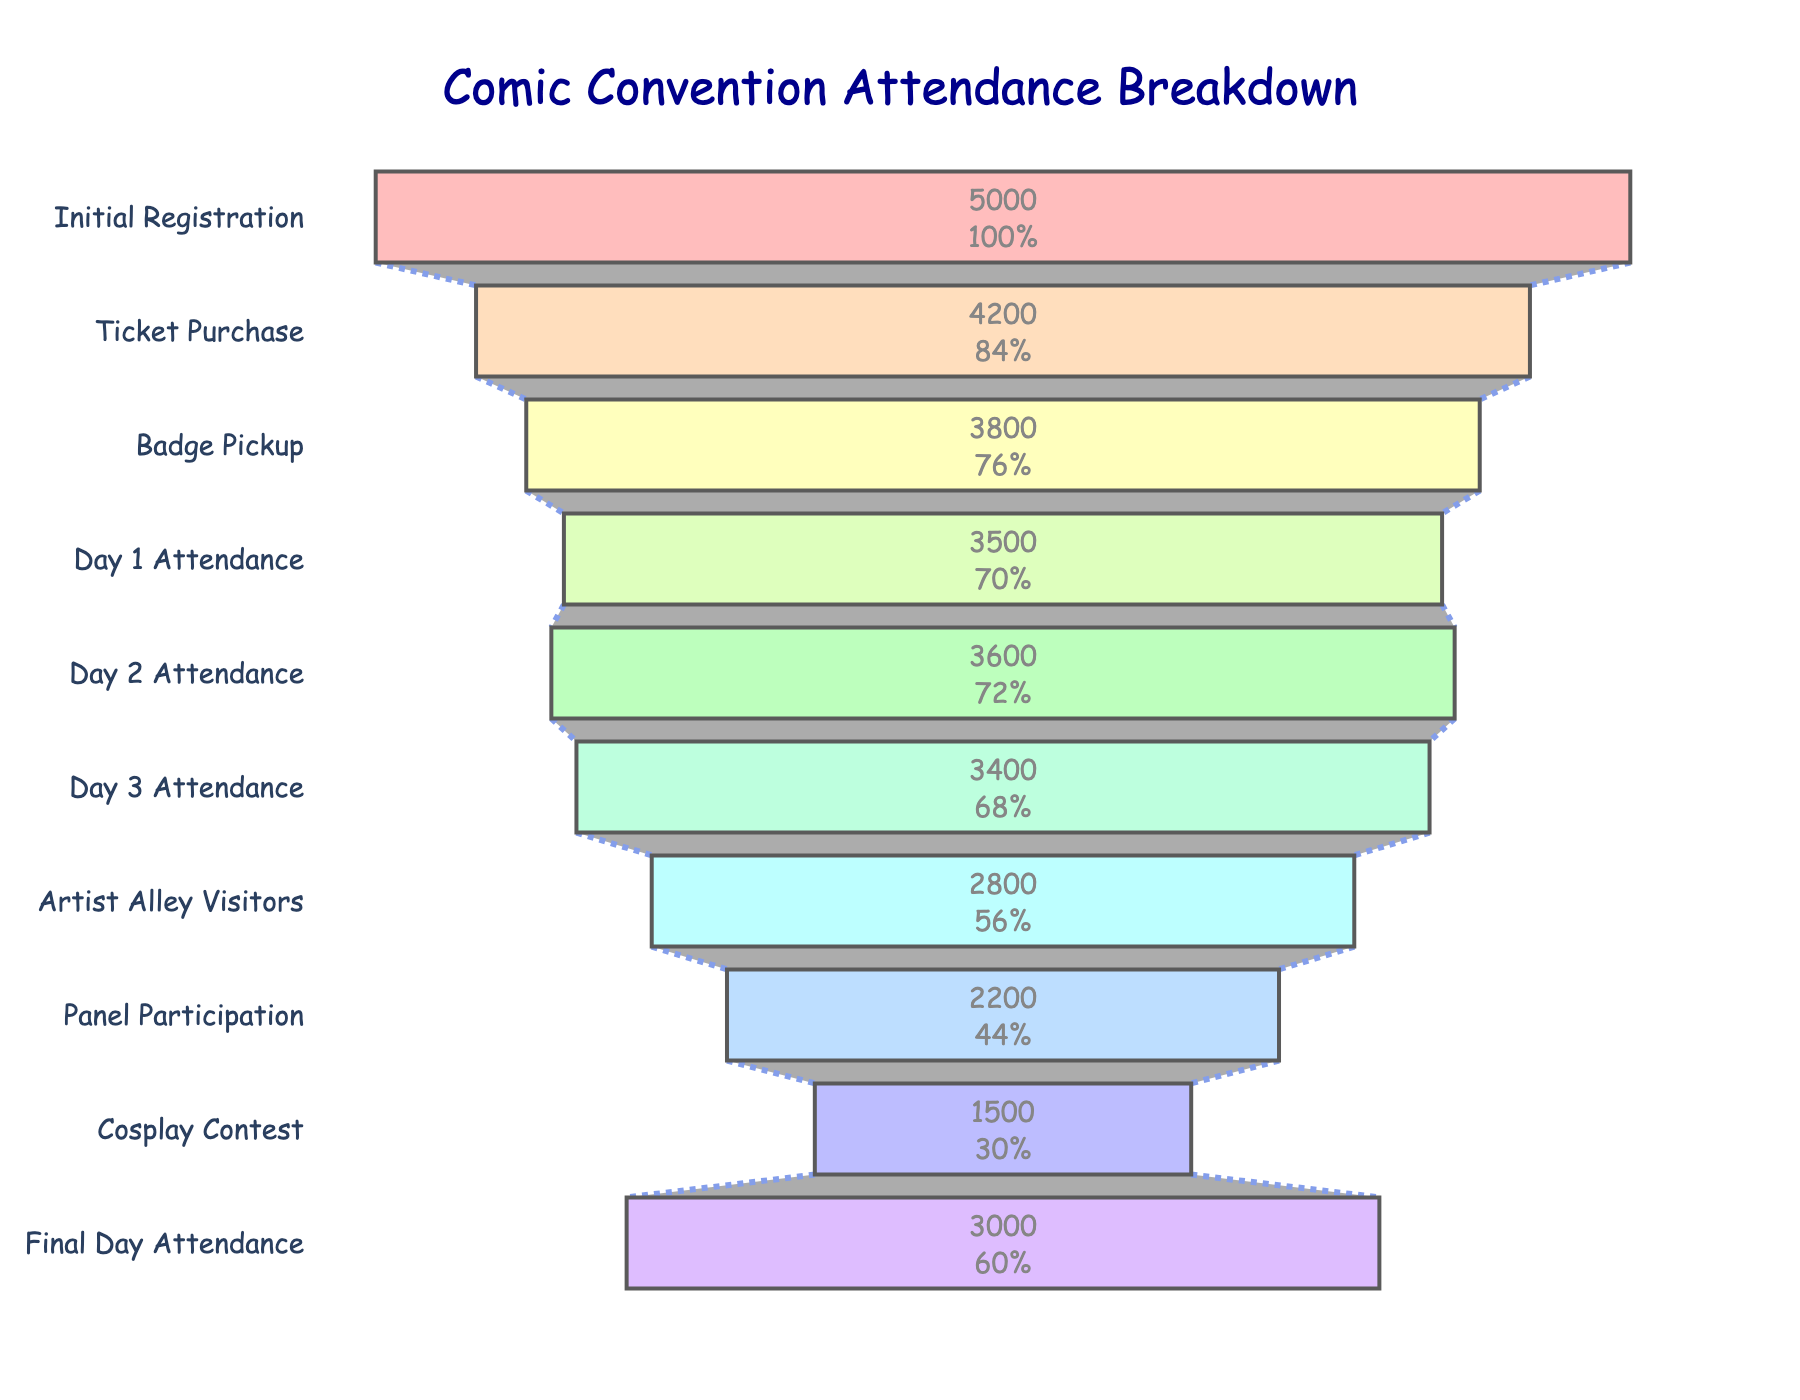What is the title of the figure? The title is displayed at the top center of the chart. It reads "Comic Convention Attendance Breakdown".
Answer: "Comic Convention Attendance Breakdown" What are the stages listed on the funnel chart? The stages listed can be read directly from the y-axis of the funnel chart. They are: Initial Registration, Ticket Purchase, Badge Pickup, Day 1 Attendance, Day 2 Attendance, Day 3 Attendance, Artist Alley Visitors, Panel Participation, Cosplay Contest, Final Day Attendance.
Answer: Initial Registration, Ticket Purchase, Badge Pickup, Day 1 Attendance, Day 2 Attendance, Day 3 Attendance, Artist Alley Visitors, Panel Participation, Cosplay Contest, Final Day Attendance How many attendees registered initially? The number of attendees for Initial Registration is shown at the top of the funnel. It is 5000.
Answer: 5000 In which stage do we see the largest drop in attendees? By examining the differences between each stage, the largest drop is from Badge Pickup (3800) to Day 1 Attendance (3500), a drop of 300.
Answer: Between Badge Pickup and Day 1 Attendance How much higher is the Final Day Attendance compared to Cosplay Contest participation? Final Day Attendance has 3000 attendees, whereas Cosplay Contest has 1500. The difference is 3000 - 1500 = 1500.
Answer: 1500 What percentage of initial registrants attended Day 2? Day 2 Attendance is 3600. The percentage relative to the initial registrants (5000) is (3600 / 5000) * 100. This equals 72%.
Answer: 72% Which stage has the lowest number of attendees? The stage with the lowest number of attendees can be identified by looking for the smallest number in the funnel chart. Cosplay Contest has 1500 attendees, the lowest.
Answer: Cosplay Contest What is the difference in attendance between Day 1 and Day 3? Day 1 Attendance is 3500 and Day 3 Attendance is 3400. The difference is 3500 - 3400 = 100.
Answer: 100 How many participants visited the Artist Alley in percentage of Day 1 attendees? Artist Alley Visitors count is 2800, and Day 1 Attendance is 3500. The percentage is (2800 / 3500) * 100. This equals 80%.
Answer: 80% By how much did attendance drop from Initial Registration to Final Day? Initial Registration is 5000, and Final Day Attendance is 3000. The drop is 5000 - 3000 = 2000.
Answer: 2000 